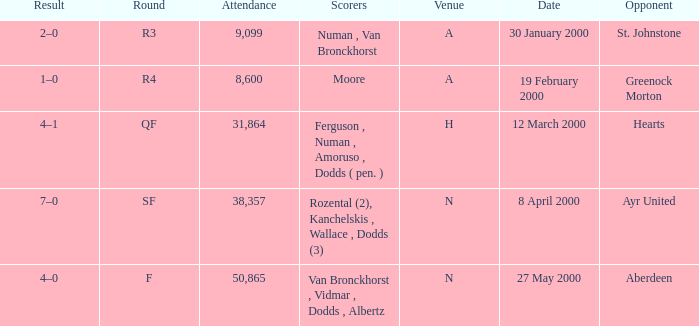Who was in a with opponent St. Johnstone? Numan , Van Bronckhorst. 